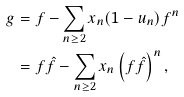<formula> <loc_0><loc_0><loc_500><loc_500>g & = f - \sum _ { n \geq 2 } x _ { n } ( 1 - u _ { n } ) f ^ { n } \\ & = f \hat { f } - \sum _ { n \geq 2 } x _ { n } \left ( f \hat { f } \right ) ^ { n } ,</formula> 